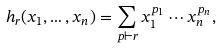Convert formula to latex. <formula><loc_0><loc_0><loc_500><loc_500>h _ { r } ( x _ { 1 } , \dots , x _ { n } ) = \sum _ { p \vdash r } x _ { 1 } ^ { p _ { 1 } } \cdots x _ { n } ^ { p _ { n } } ,</formula> 